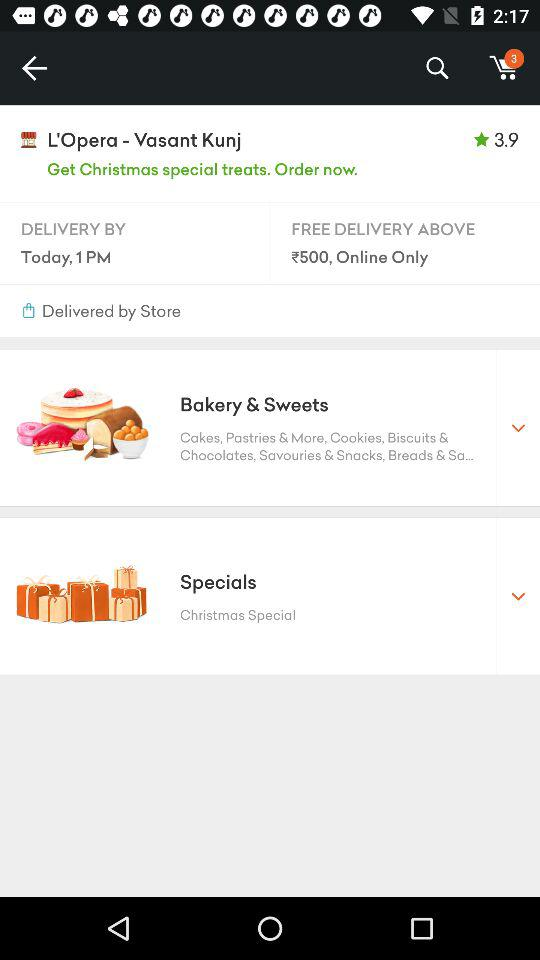What is the rating for "L'Opera - Vasant Kunj"? The rating is 3.9. 